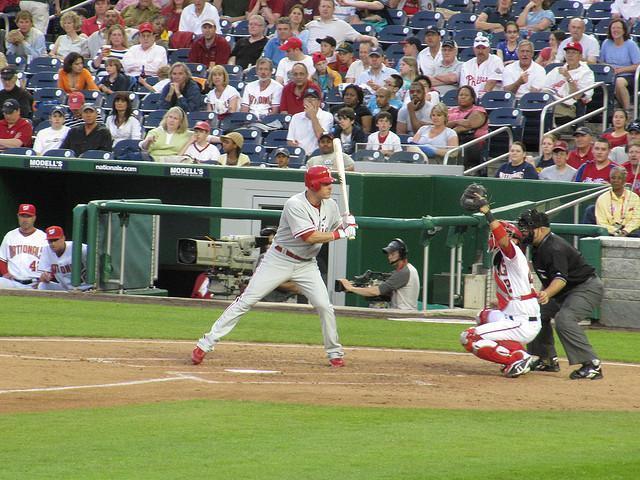Where is the ball?
Make your selection and explain in format: 'Answer: answer
Rationale: rationale.'
Options: Pitcher's hand, coach, batters glove, catcher's glove. Answer: catcher's glove.
Rationale: It's why the batter is looking at him 